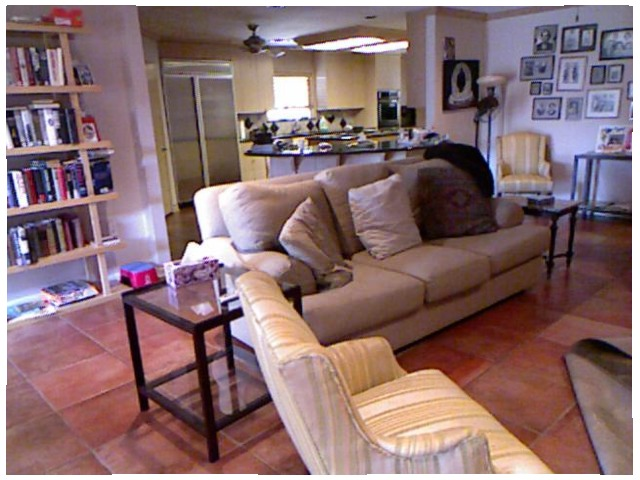<image>
Is there a pillow on the chair? No. The pillow is not positioned on the chair. They may be near each other, but the pillow is not supported by or resting on top of the chair. 